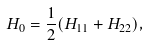Convert formula to latex. <formula><loc_0><loc_0><loc_500><loc_500>H _ { 0 } = \frac { 1 } { 2 } ( H _ { 1 1 } + H _ { 2 2 } ) ,</formula> 